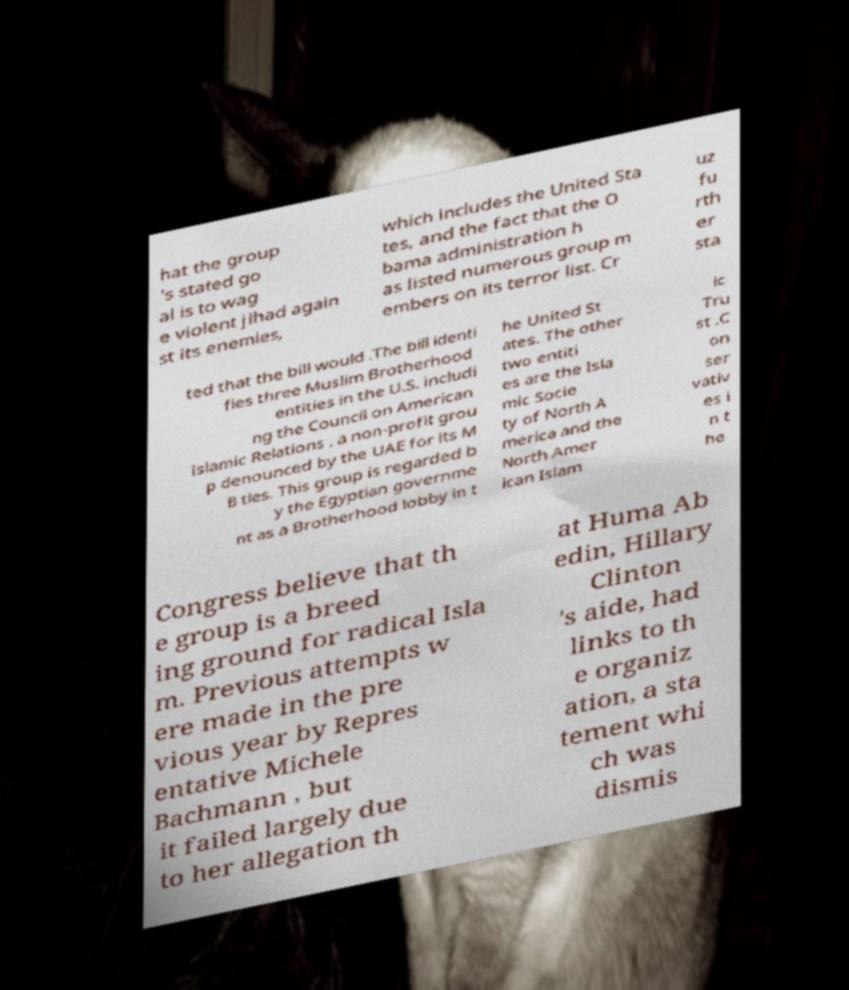Could you assist in decoding the text presented in this image and type it out clearly? hat the group 's stated go al is to wag e violent jihad again st its enemies, which includes the United Sta tes, and the fact that the O bama administration h as listed numerous group m embers on its terror list. Cr uz fu rth er sta ted that the bill would .The bill identi fies three Muslim Brotherhood entities in the U.S. includi ng the Council on American Islamic Relations , a non-profit grou p denounced by the UAE for its M B ties. This group is regarded b y the Egyptian governme nt as a Brotherhood lobby in t he United St ates. The other two entiti es are the Isla mic Socie ty of North A merica and the North Amer ican Islam ic Tru st .C on ser vativ es i n t he Congress believe that th e group is a breed ing ground for radical Isla m. Previous attempts w ere made in the pre vious year by Repres entative Michele Bachmann , but it failed largely due to her allegation th at Huma Ab edin, Hillary Clinton 's aide, had links to th e organiz ation, a sta tement whi ch was dismis 